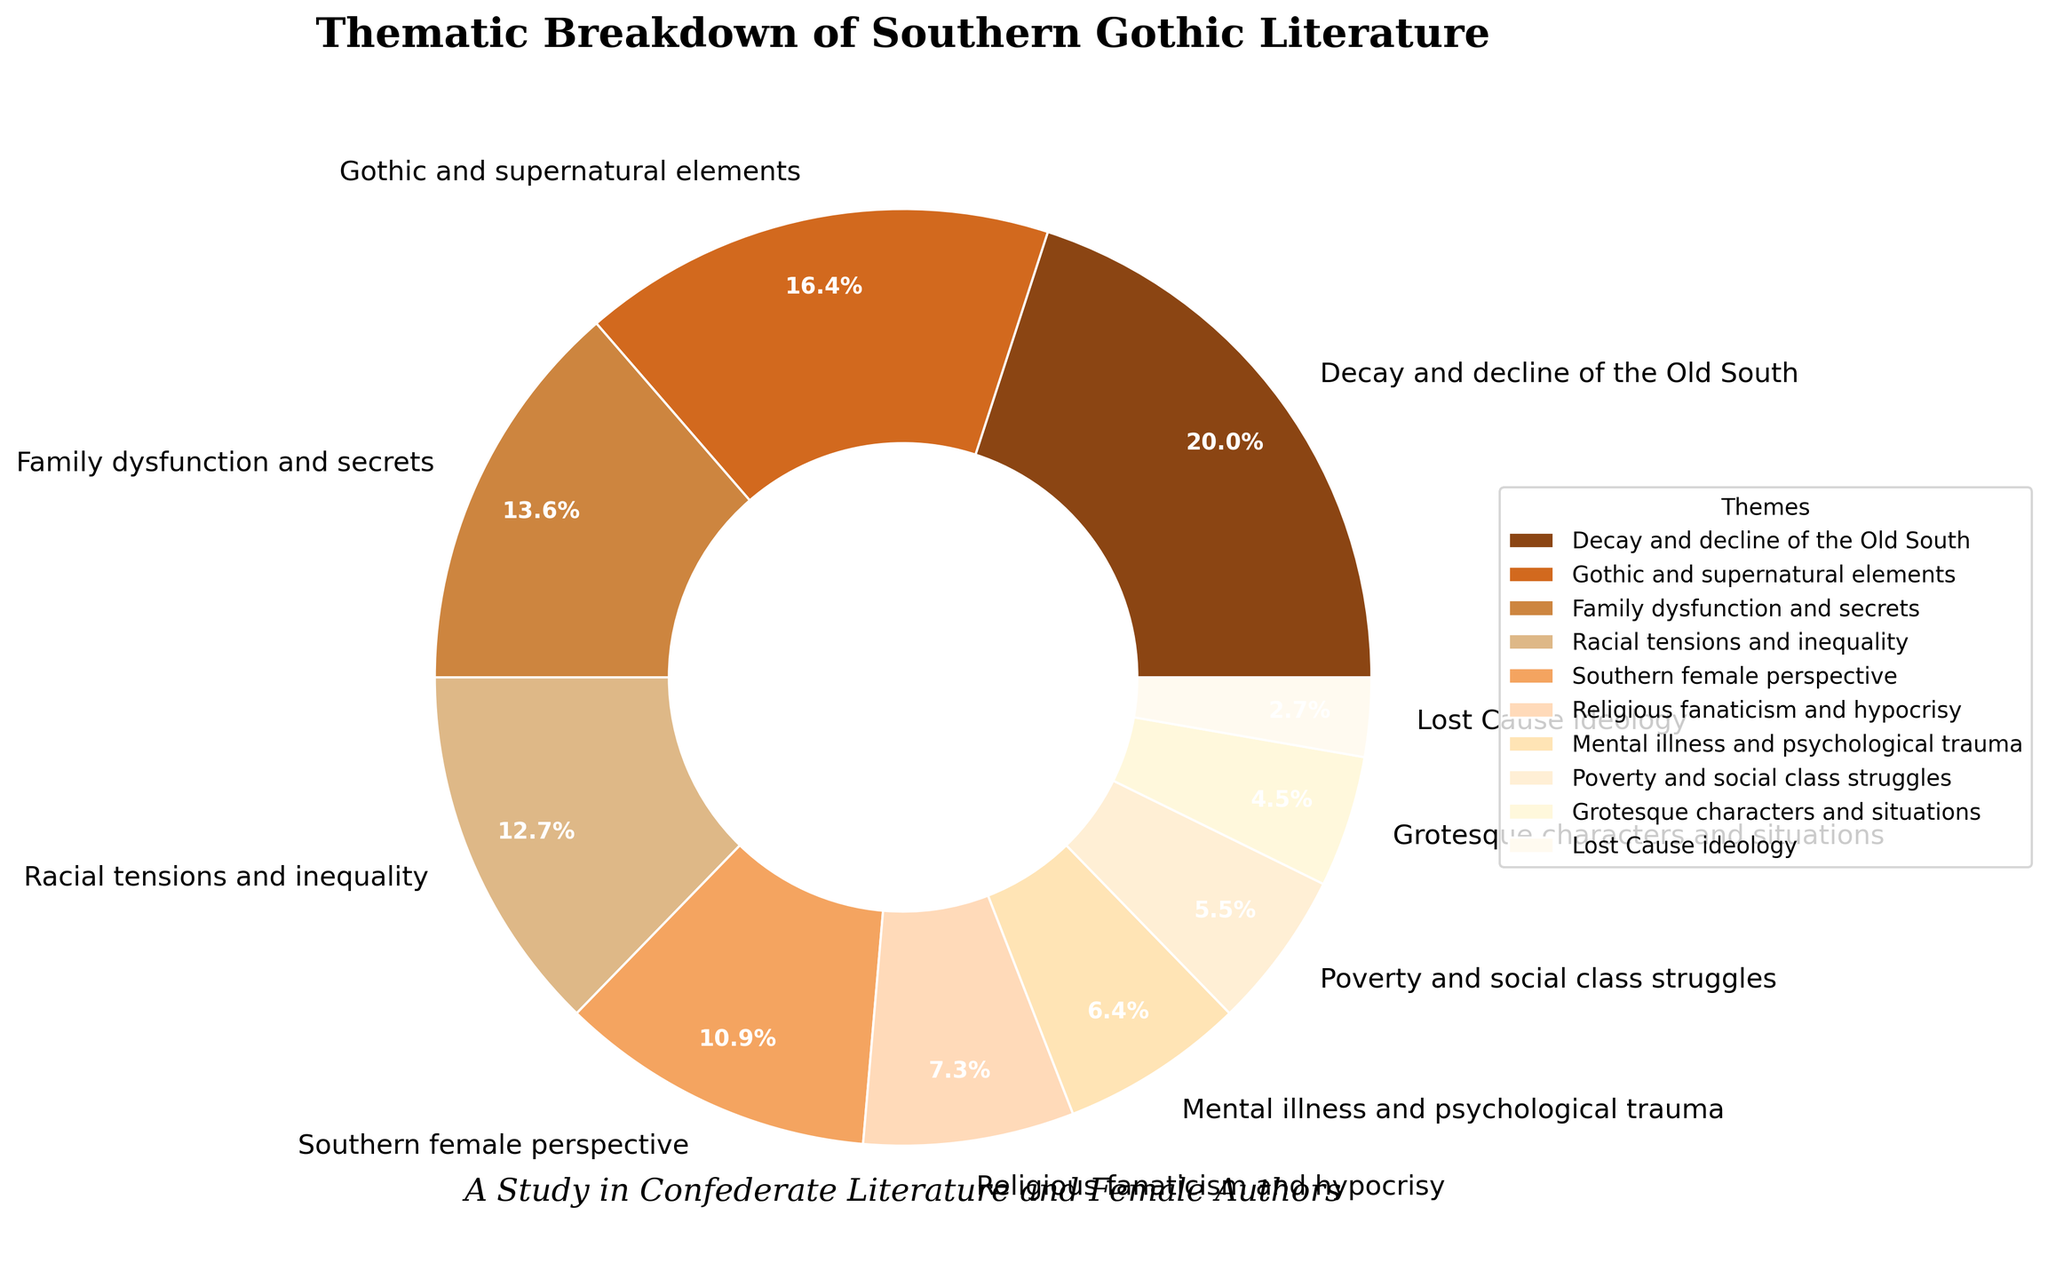What is the combined percentage of themes related to decay and decline of the Old South, gothic and supernatural elements, and family dysfunction and secrets? The percentages for these themes are 22%, 18%, and 15%, respectively. Adding them together: 22 + 18 + 15 = 55.
Answer: 55% Which theme has a higher percentage: Southern female perspective or racial tensions and inequality? The percentage for Southern female perspective is 12%, while racial tensions and inequality is 14%. Comparing these values, 14% (racial tensions and inequality) is higher than 12% (Southern female perspective).
Answer: Racial tensions and inequality What is the difference in percentage between religious fanaticism and hypocrisy and mental illness and psychological trauma? The percentage for religious fanaticism and hypocrisy is 8%, and for mental illness and psychological trauma, it is 7%. The difference can be calculated as 8 - 7 = 1.
Answer: 1% Which theme has the smallest visual wedge in the pie chart? The pie chart shows the Lost Cause ideology with the smallest percentage at 3%, making it have the smallest wedge.
Answer: Lost Cause ideology What combined percentage do family dysfunction and secrets, and grotesque characters and situations contribute to the thematic breakdown? The percentages for family dysfunction and secrets and grotesque characters and situations are 15% and 5%, respectively. Adding them together: 15 + 5 = 20.
Answer: 20% How many themes have a percentage greater than 10%? The percentages of themes are: 22%, 18%, 15%, 14%, and 12%. All of these are above 10%. Therefore, the total number of themes with a percentage greater than 10% is 5.
Answer: 5 What theme contributes the least to the thematic breakdown, and what is its percentage? According to the data, the Lost Cause ideology has the smallest percentage at 3%.
Answer: Lost Cause ideology, 3% Which is more prominent: decay and decline of the Old South or mental illness and psychological trauma? Comparing the percentages of decay and decline of the Old South (22%) and mental illness and psychological trauma (7%), it's evident that 22% is greater than 7%.
Answer: Decay and decline of the Old South What is the percentage difference between Southern female perspective and poverty and social class struggles? The percentage for Southern female perspective is 12%, and for poverty and social class struggles, it is 6%. The difference can be calculated as 12 - 6 = 6.
Answer: 6% 